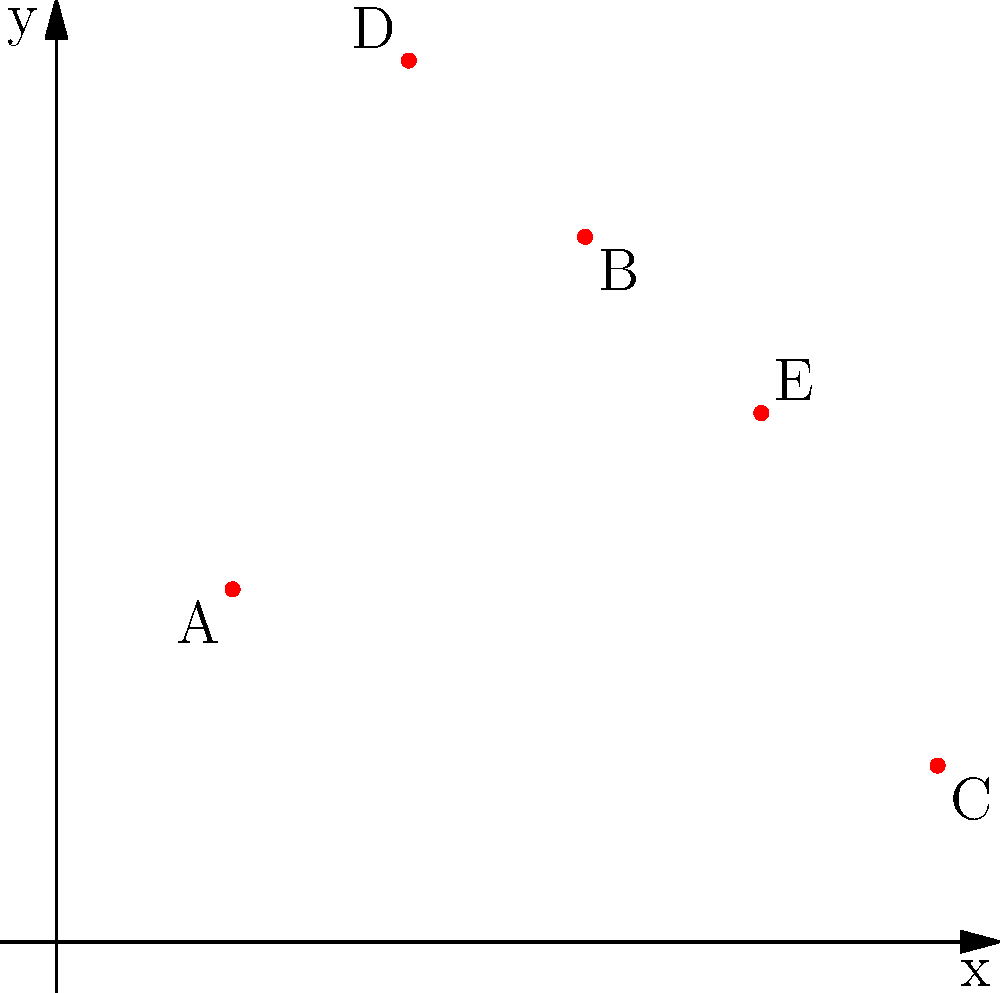In your encryption key distribution system, you've plotted five secure key exchange points (A, B, C, D, E) on a 2D coordinate plane. If an attacker can compromise any point within a radius of 2 units from the origin (0,0), how many of your key exchange points remain secure? To solve this problem, we need to follow these steps:

1. Identify the coordinates of each point:
   A: (1,2)
   B: (3,4)
   C: (5,1)
   D: (2,5)
   E: (4,3)

2. Calculate the distance of each point from the origin (0,0) using the distance formula:
   $d = \sqrt{x^2 + y^2}$

3. Compare each distance to the compromise radius of 2 units:

   For A: $d_A = \sqrt{1^2 + 2^2} = \sqrt{5} \approx 2.24 > 2$
   For B: $d_B = \sqrt{3^2 + 4^2} = \sqrt{25} = 5 > 2$
   For C: $d_C = \sqrt{5^2 + 1^2} = \sqrt{26} \approx 5.10 > 2$
   For D: $d_D = \sqrt{2^2 + 5^2} = \sqrt{29} \approx 5.39 > 2$
   For E: $d_E = \sqrt{4^2 + 3^2} = \sqrt{25} = 5 > 2$

4. Count the number of points with distances greater than 2:
   All five points (A, B, C, D, E) have distances greater than 2 from the origin.

Therefore, all five key exchange points remain secure from the attacker's compromise radius.
Answer: 5 points 